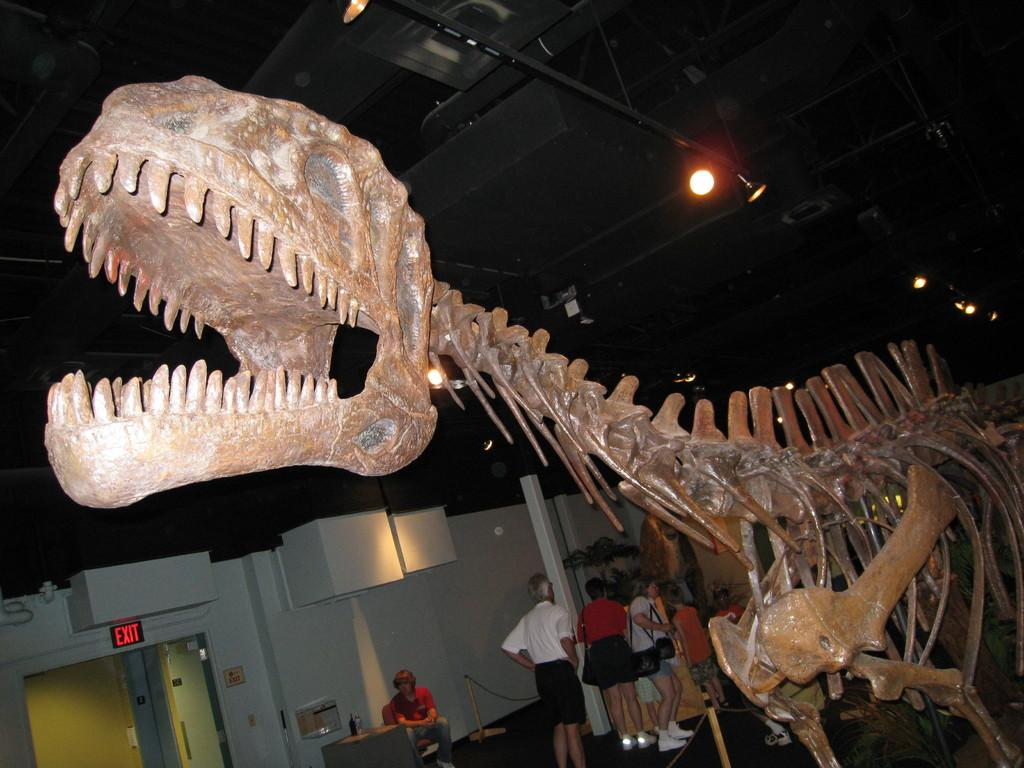What is the main subject of the image? There is a dinosaur skeleton in the image. What else can be seen in the image besides the dinosaur skeleton? There are people standing in the middle of the image. Where is the exit door located in the image? The exit door is at the bottom of the image. What can be seen at the top of the image? There is a light at the top of the image. What type of yam is being used as a payment method in the image? There is no yam or payment method present in the image. What invention is being demonstrated by the people in the image? The image does not depict any specific invention being demonstrated by the people. 